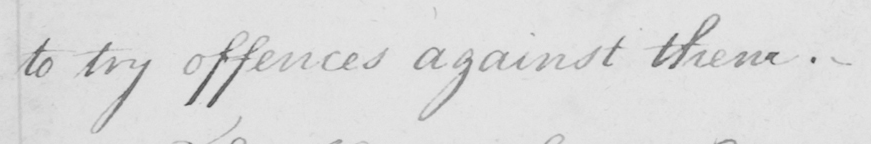Please transcribe the handwritten text in this image. to try offences against them . 